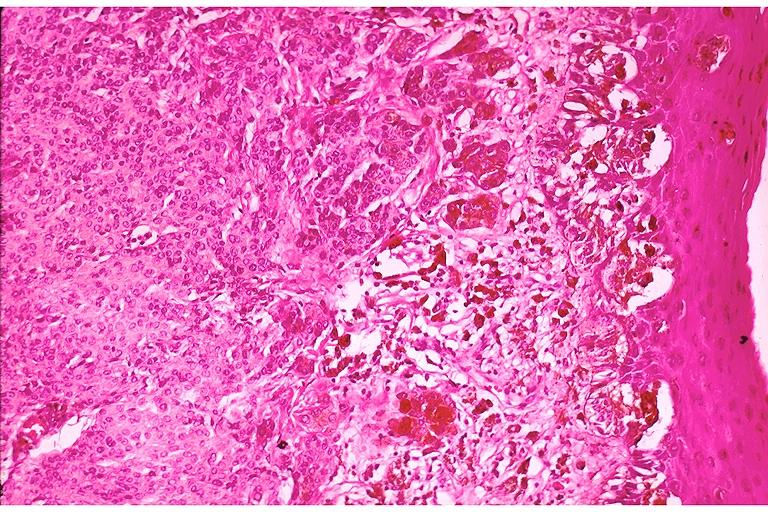s excellent example present?
Answer the question using a single word or phrase. No 